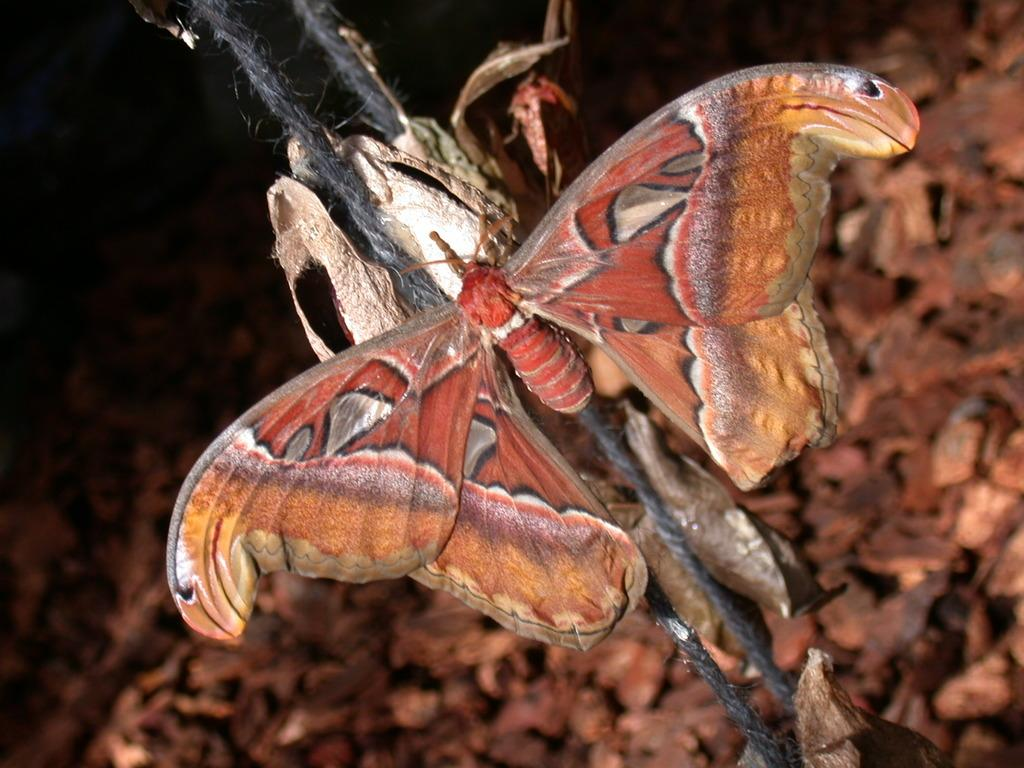What type of creature can be seen in the image? There is an insect in the image. What is hanging from threads in the image? There are objects on threads in the image. What can be seen in the background of the image, although it is blurred? There are objects visible in the blurred background of the image. What type of cap can be seen on the insect in the image? There is no cap present on the insect in the image. What land or border is visible in the image? The image does not depict any land or borders; it features in the image include an insect, objects on threads, and a blurred background. 